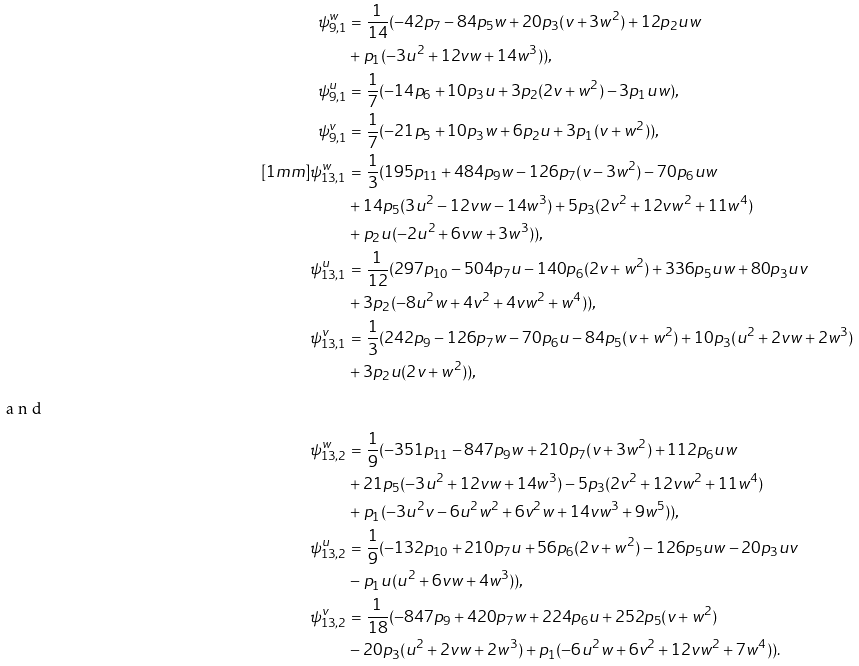Convert formula to latex. <formula><loc_0><loc_0><loc_500><loc_500>\psi _ { 9 , 1 } ^ { w } & = \frac { 1 } { 1 4 } ( - 4 2 p _ { 7 } - 8 4 p _ { 5 } w + 2 0 p _ { 3 } ( v + 3 w ^ { 2 } ) + 1 2 p _ { 2 } u w \\ & + p _ { 1 } ( - 3 u ^ { 2 } + 1 2 v w + 1 4 w ^ { 3 } ) ) , \\ \psi _ { 9 , 1 } ^ { u } & = \frac { 1 } { 7 } ( - 1 4 p _ { 6 } + 1 0 p _ { 3 } u + 3 p _ { 2 } ( 2 v + w ^ { 2 } ) - 3 p _ { 1 } u w ) , \\ \psi _ { 9 , 1 } ^ { v } & = \frac { 1 } { 7 } ( - 2 1 p _ { 5 } + 1 0 p _ { 3 } w + 6 p _ { 2 } u + 3 p _ { 1 } ( v + w ^ { 2 } ) ) , \\ [ 1 m m ] \psi _ { 1 3 , 1 } ^ { w } & = \frac { 1 } { 3 } ( 1 9 5 p _ { 1 1 } + 4 8 4 p _ { 9 } w - 1 2 6 p _ { 7 } ( v - 3 w ^ { 2 } ) - 7 0 p _ { 6 } u w \\ & + 1 4 p _ { 5 } ( 3 u ^ { 2 } - 1 2 v w - 1 4 w ^ { 3 } ) + 5 p _ { 3 } ( 2 v ^ { 2 } + 1 2 v w ^ { 2 } + 1 1 w ^ { 4 } ) \\ & + p _ { 2 } u ( - 2 u ^ { 2 } + 6 v w + 3 w ^ { 3 } ) ) , \\ \psi _ { 1 3 , 1 } ^ { u } & = \frac { 1 } { 1 2 } ( 2 9 7 p _ { 1 0 } - 5 0 4 p _ { 7 } u - 1 4 0 p _ { 6 } ( 2 v + w ^ { 2 } ) + 3 3 6 p _ { 5 } u w + 8 0 p _ { 3 } u v \\ & + 3 p _ { 2 } ( - 8 u ^ { 2 } w + 4 v ^ { 2 } + 4 v w ^ { 2 } + w ^ { 4 } ) ) , \\ \psi _ { 1 3 , 1 } ^ { v } & = \frac { 1 } { 3 } ( 2 4 2 p _ { 9 } - 1 2 6 p _ { 7 } w - 7 0 p _ { 6 } u - 8 4 p _ { 5 } ( v + w ^ { 2 } ) + 1 0 p _ { 3 } ( u ^ { 2 } + 2 v w + 2 w ^ { 3 } ) \\ & + 3 p _ { 2 } u ( 2 v + w ^ { 2 } ) ) , \\ \intertext { a n d } \psi _ { 1 3 , 2 } ^ { w } & = \frac { 1 } { 9 } ( - 3 5 1 p _ { 1 1 } - 8 4 7 p _ { 9 } w + 2 1 0 p _ { 7 } ( v + 3 w ^ { 2 } ) + 1 1 2 p _ { 6 } u w \\ & + 2 1 p _ { 5 } ( - 3 u ^ { 2 } + 1 2 v w + 1 4 w ^ { 3 } ) - 5 p _ { 3 } ( 2 v ^ { 2 } + 1 2 v w ^ { 2 } + 1 1 w ^ { 4 } ) \\ & + p _ { 1 } ( - 3 u ^ { 2 } v - 6 u ^ { 2 } w ^ { 2 } + 6 v ^ { 2 } w + 1 4 v w ^ { 3 } + 9 w ^ { 5 } ) ) , \\ \psi _ { 1 3 , 2 } ^ { u } & = \frac { 1 } { 9 } ( - 1 3 2 p _ { 1 0 } + 2 1 0 p _ { 7 } u + 5 6 p _ { 6 } ( 2 v + w ^ { 2 } ) - 1 2 6 p _ { 5 } u w - 2 0 p _ { 3 } u v \\ & - p _ { 1 } u ( u ^ { 2 } + 6 v w + 4 w ^ { 3 } ) ) , \\ \psi _ { 1 3 , 2 } ^ { v } & = \frac { 1 } { 1 8 } ( - 8 4 7 p _ { 9 } + 4 2 0 p _ { 7 } w + 2 2 4 p _ { 6 } u + 2 5 2 p _ { 5 } ( v + w ^ { 2 } ) \\ & - 2 0 p _ { 3 } ( u ^ { 2 } + 2 v w + 2 w ^ { 3 } ) + p _ { 1 } ( - 6 u ^ { 2 } w + 6 v ^ { 2 } + 1 2 v w ^ { 2 } + 7 w ^ { 4 } ) ) .</formula> 